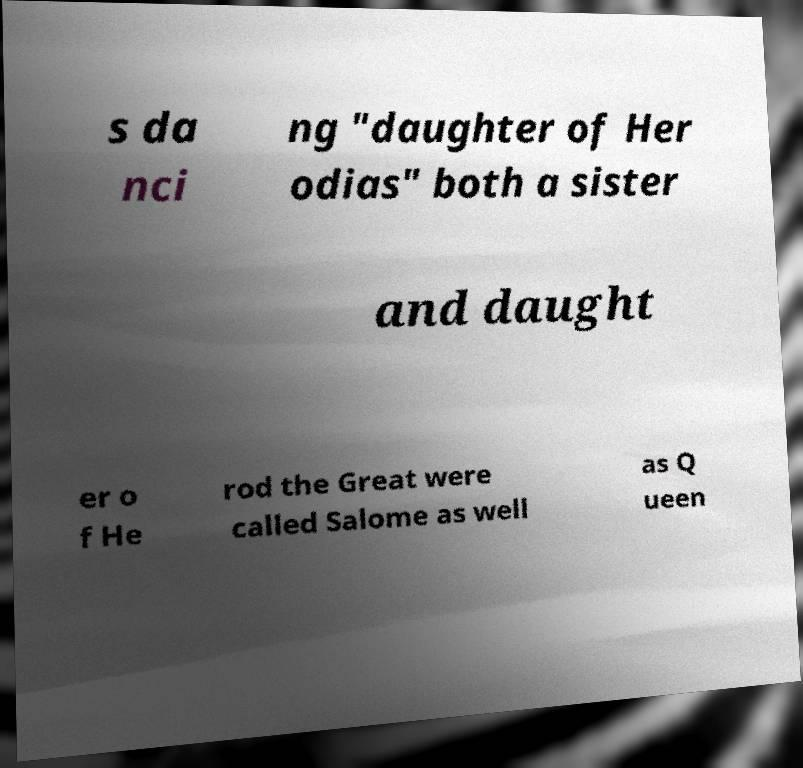There's text embedded in this image that I need extracted. Can you transcribe it verbatim? s da nci ng "daughter of Her odias" both a sister and daught er o f He rod the Great were called Salome as well as Q ueen 